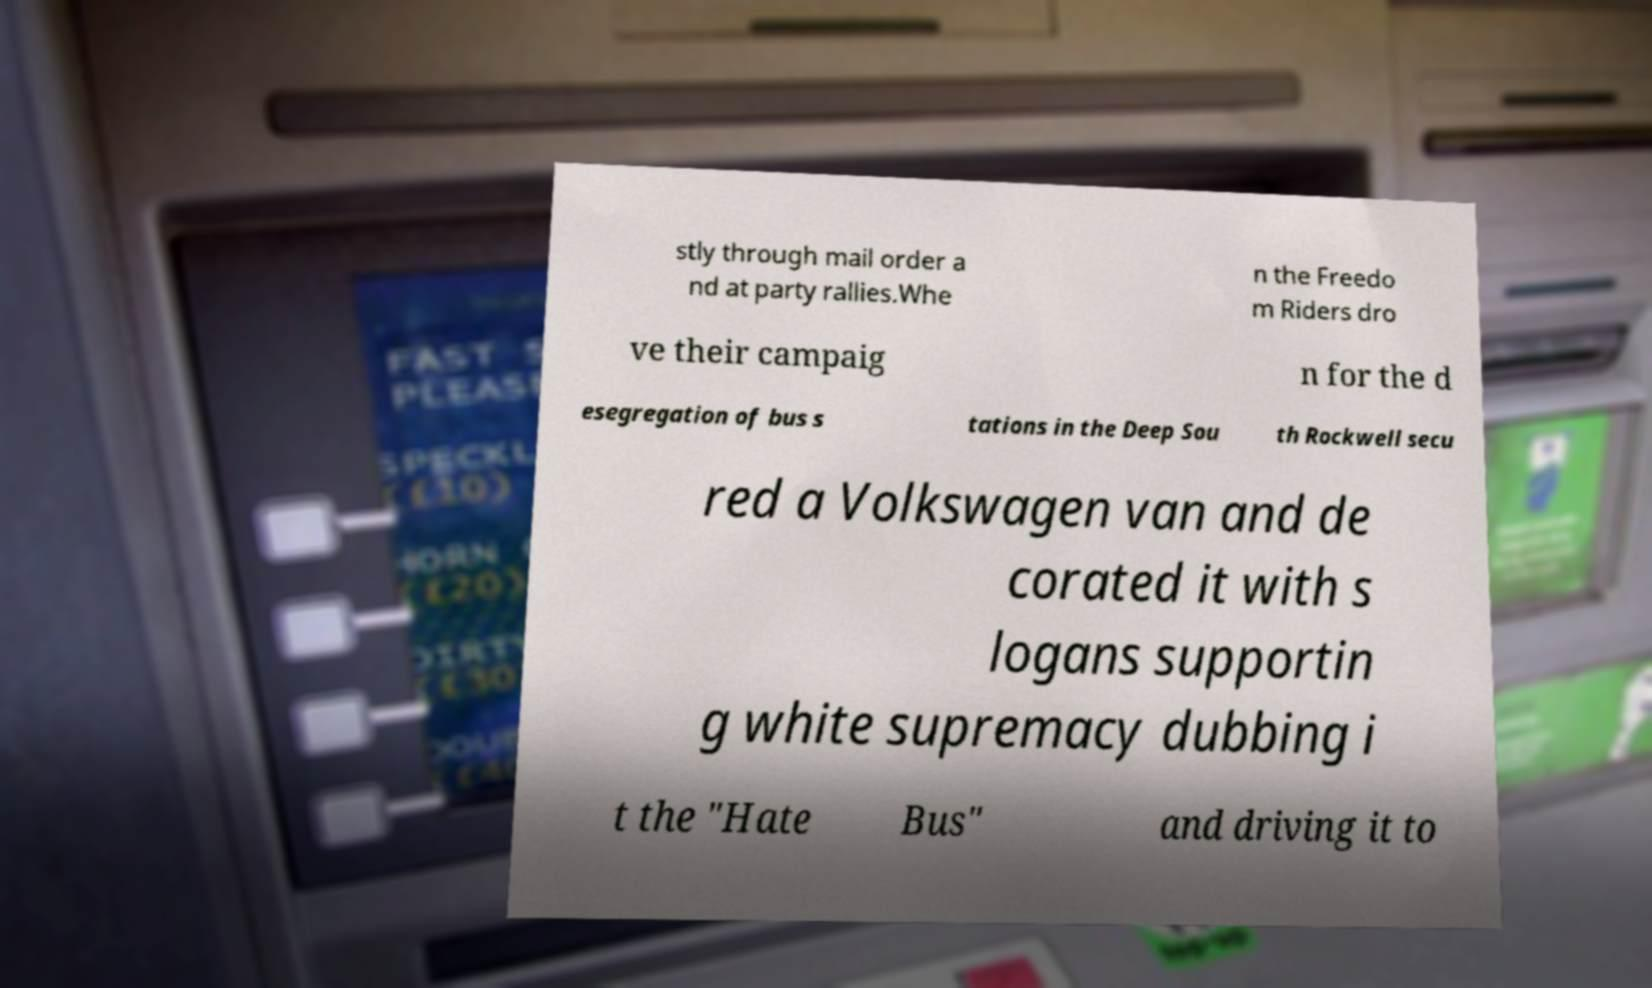There's text embedded in this image that I need extracted. Can you transcribe it verbatim? stly through mail order a nd at party rallies.Whe n the Freedo m Riders dro ve their campaig n for the d esegregation of bus s tations in the Deep Sou th Rockwell secu red a Volkswagen van and de corated it with s logans supportin g white supremacy dubbing i t the "Hate Bus" and driving it to 